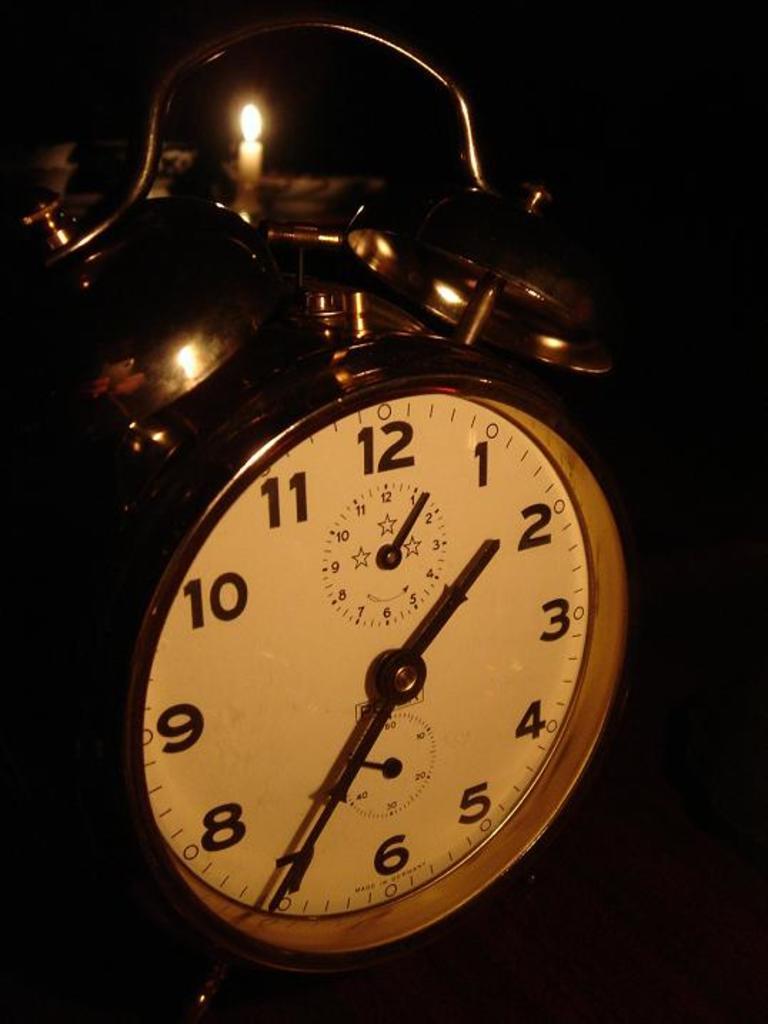What number is the little hand on?
Your answer should be very brief. 2. What time is it?
Offer a terse response. 1:35. 